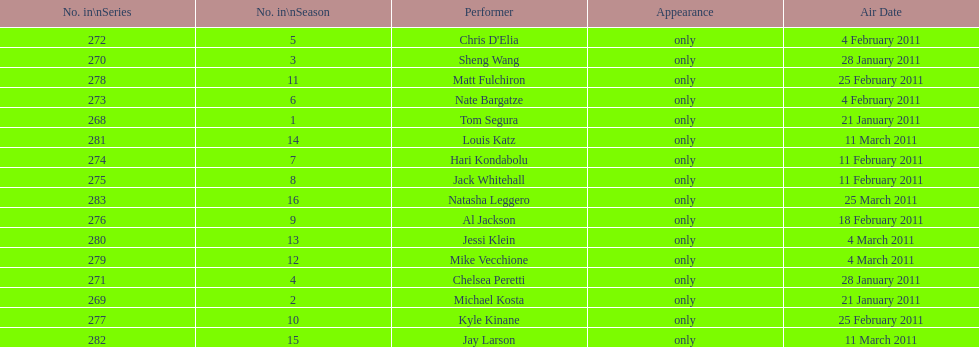How many weeks did season 15 of comedy central presents span? 9. 